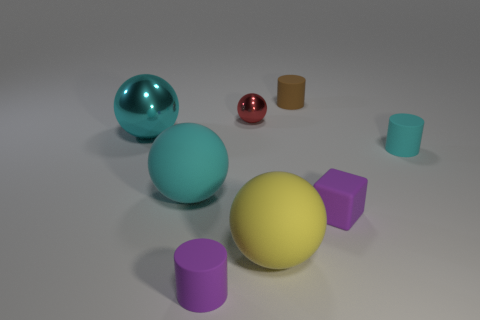What number of cyan cylinders are the same size as the cyan metal sphere?
Ensure brevity in your answer.  0. What material is the other yellow object that is the same shape as the tiny shiny thing?
Your response must be concise. Rubber. There is a thing that is in front of the big yellow ball; what is its color?
Your answer should be very brief. Purple. Is the number of tiny matte cylinders that are in front of the tiny rubber block greater than the number of small yellow rubber cubes?
Make the answer very short. Yes. The rubber block is what color?
Your response must be concise. Purple. What shape is the tiny rubber thing that is behind the cyan matte object to the right of the cyan rubber object that is left of the brown rubber object?
Provide a succinct answer. Cylinder. There is a small cylinder that is right of the small metal thing and in front of the small red shiny object; what material is it?
Your answer should be compact. Rubber. The large thing on the right side of the cyan rubber thing that is left of the tiny purple rubber cylinder is what shape?
Provide a short and direct response. Sphere. Are there any other things that are the same color as the large shiny ball?
Your response must be concise. Yes. Does the red metal thing have the same size as the rubber cylinder that is left of the yellow matte sphere?
Provide a short and direct response. Yes. 